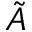<formula> <loc_0><loc_0><loc_500><loc_500>\tilde { A }</formula> 